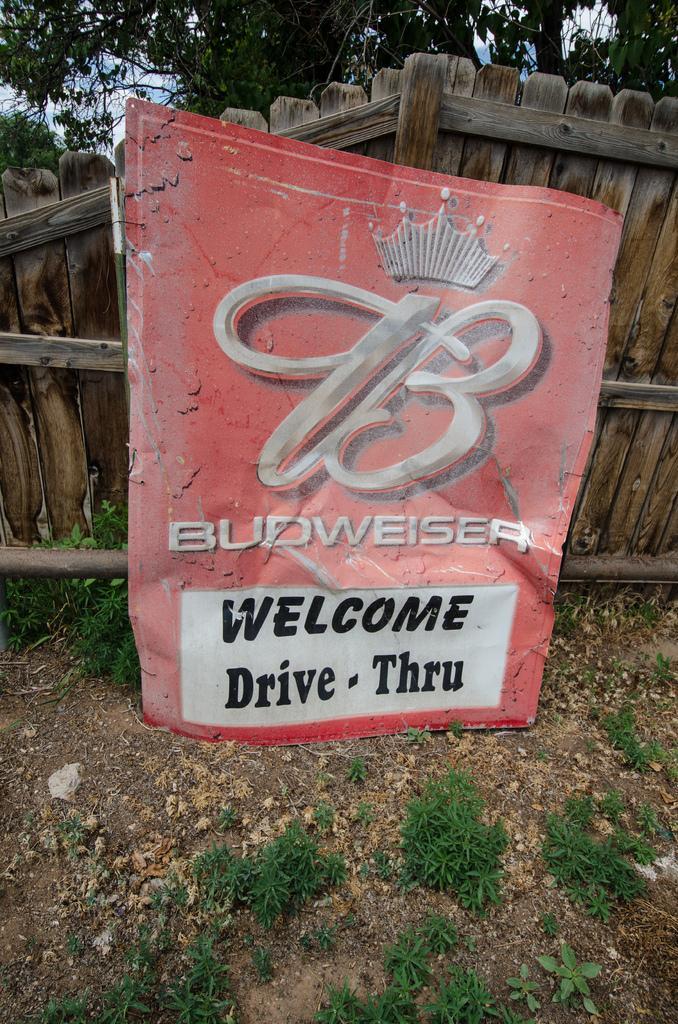Describe this image in one or two sentences. In this image I can see a board which is in red color. Background I can see a wooden door, trees in green color and sky in white and blue color. 